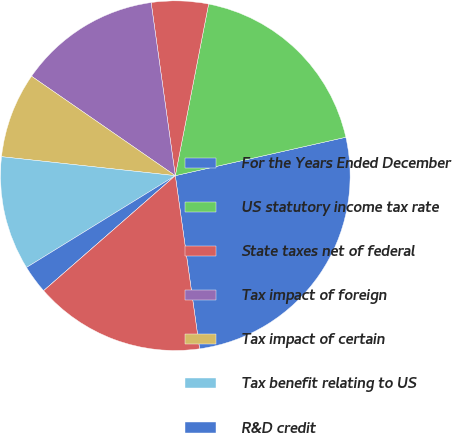Convert chart to OTSL. <chart><loc_0><loc_0><loc_500><loc_500><pie_chart><fcel>For the Years Ended December<fcel>US statutory income tax rate<fcel>State taxes net of federal<fcel>Tax impact of foreign<fcel>Tax impact of certain<fcel>Tax benefit relating to US<fcel>R&D credit<fcel>Other<fcel>Effective income tax rate<nl><fcel>26.31%<fcel>18.42%<fcel>5.26%<fcel>13.16%<fcel>7.9%<fcel>10.53%<fcel>2.63%<fcel>0.0%<fcel>15.79%<nl></chart> 